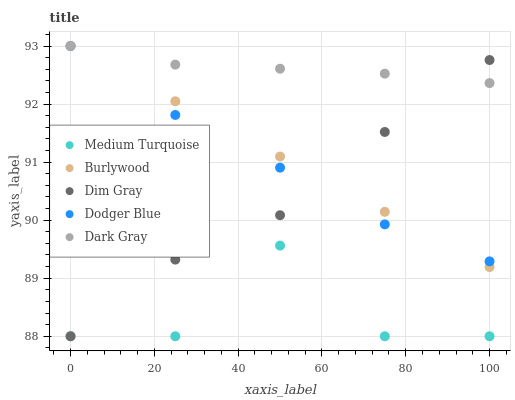Does Medium Turquoise have the minimum area under the curve?
Answer yes or no. Yes. Does Dark Gray have the maximum area under the curve?
Answer yes or no. Yes. Does Dim Gray have the minimum area under the curve?
Answer yes or no. No. Does Dim Gray have the maximum area under the curve?
Answer yes or no. No. Is Burlywood the smoothest?
Answer yes or no. Yes. Is Medium Turquoise the roughest?
Answer yes or no. Yes. Is Dark Gray the smoothest?
Answer yes or no. No. Is Dark Gray the roughest?
Answer yes or no. No. Does Dim Gray have the lowest value?
Answer yes or no. Yes. Does Dark Gray have the lowest value?
Answer yes or no. No. Does Dodger Blue have the highest value?
Answer yes or no. Yes. Does Dim Gray have the highest value?
Answer yes or no. No. Is Medium Turquoise less than Dodger Blue?
Answer yes or no. Yes. Is Burlywood greater than Medium Turquoise?
Answer yes or no. Yes. Does Dodger Blue intersect Burlywood?
Answer yes or no. Yes. Is Dodger Blue less than Burlywood?
Answer yes or no. No. Is Dodger Blue greater than Burlywood?
Answer yes or no. No. Does Medium Turquoise intersect Dodger Blue?
Answer yes or no. No. 